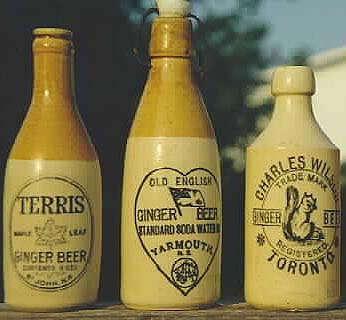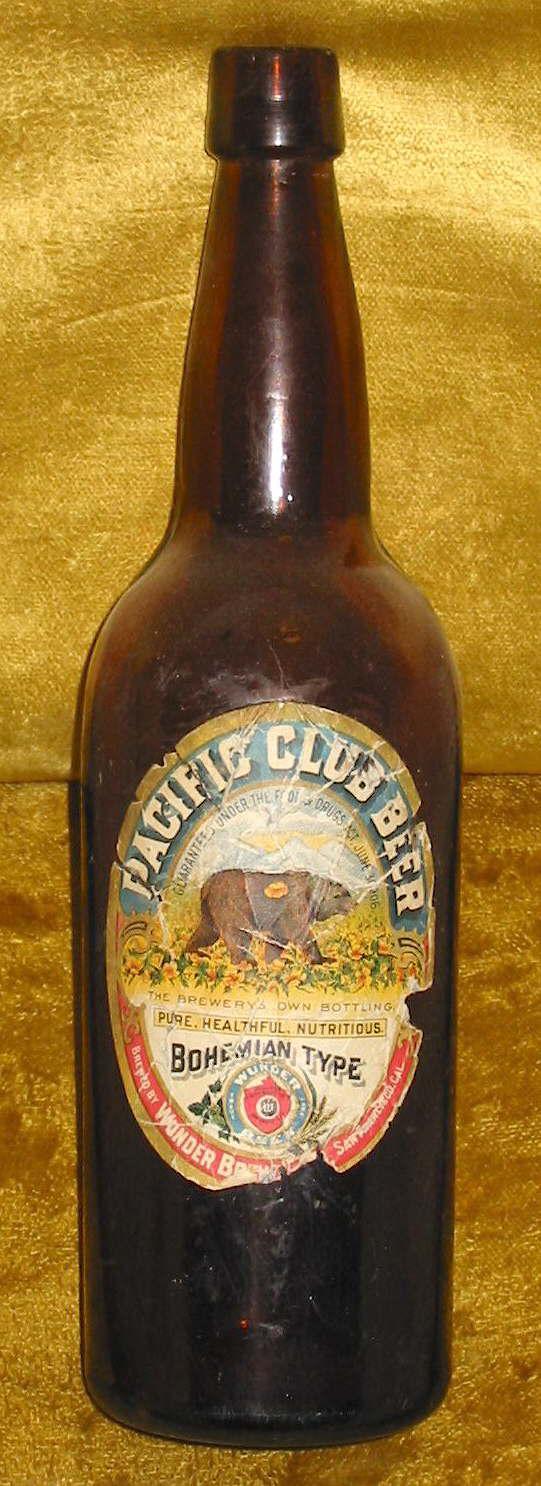The first image is the image on the left, the second image is the image on the right. Evaluate the accuracy of this statement regarding the images: "Two cobalt blue bottles are sitting among at least 18 other colorful bottles.". Is it true? Answer yes or no. No. The first image is the image on the left, the second image is the image on the right. For the images shown, is this caption "The left image contains three or more different bottles while the right image contains only a single bottle." true? Answer yes or no. Yes. 